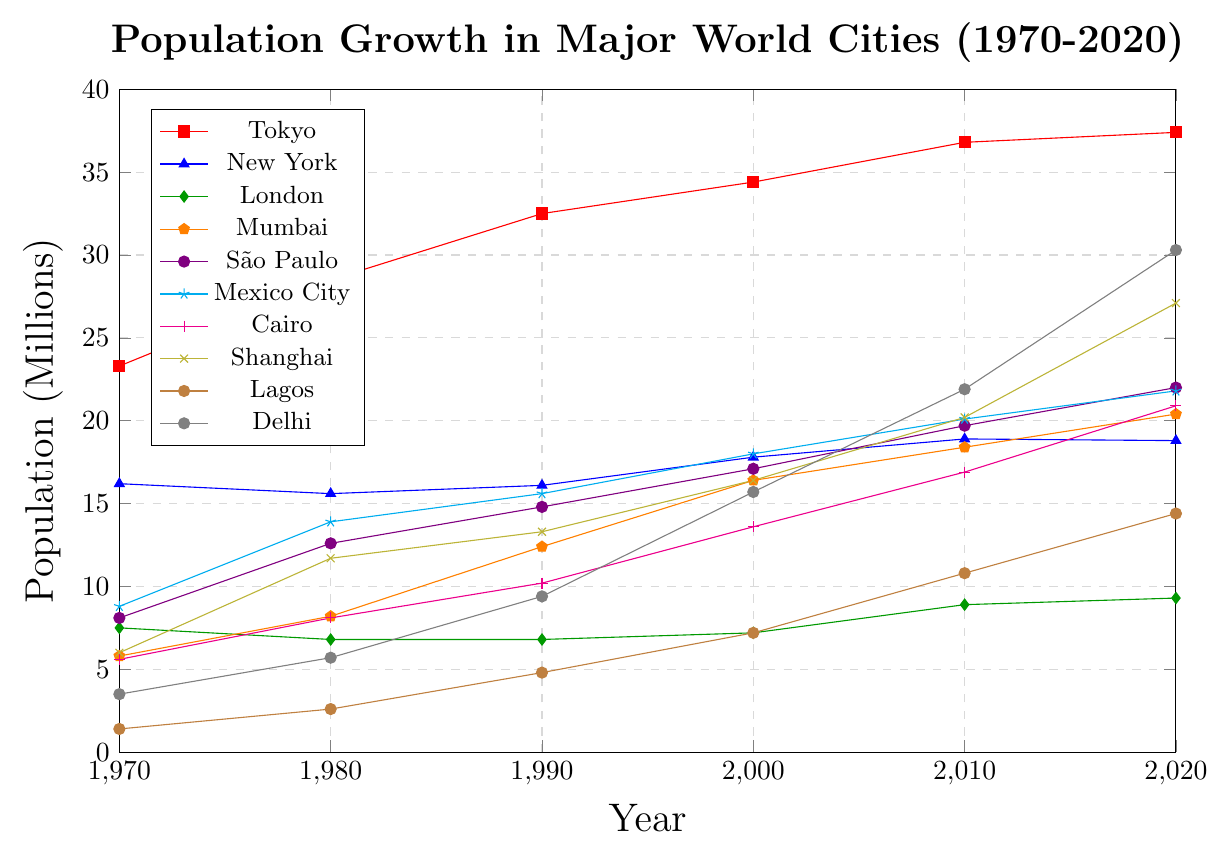Which city had the highest population growth between 1970 and 2020? To determine the highest population growth, subtract the 1970 population from the 2020 population for each city. Tokyo: 37.4 - 23.3 = 14.1, New York: 18.8 - 16.2 = 2.6, London: 9.3 - 7.5 = 1.8, Mumbai: 20.4 - 5.8 = 14.6, São Paulo: 22.0 - 8.1 = 13.9, Mexico City: 21.8 - 8.8 = 13.0, Cairo: 20.9 - 5.6 = 15.3, Shanghai: 27.1 - 6.0 = 21.1, Lagos: 14.4 - 1.4 = 13.0, Delhi: 30.3 - 3.5 = 26.8. The highest is Delhi with 26.8 million.
Answer: Delhi Which city had a population decline between 1970 and 1980? Look at the population values from 1970 and 1980 for each city to see if there was a decline. Tokyo: 23.3 to 28.5, New York: 16.2 to 15.6, London: 7.5 to 6.8, Mumbai: 5.8 to 8.2, São Paulo: 8.1 to 12.6, Mexico City: 8.8 to 13.9, Cairo: 5.6 to 8.1, Shanghai: 6.0 to 11.7, Lagos: 1.4 to 2.6, Delhi: 3.5 to 5.7. Both New York and London experienced declines.
Answer: New York, London Which city saw the fastest growth between 2000 and 2020? Calculate the difference in population between 2000 and 2020 for each city. Tokyo: 37.4 - 34.4 = 3, New York: 18.8 - 17.8 = 1, London: 9.3 - 7.2 = 2.1, Mumbai: 20.4 - 16.4 = 4, São Paulo: 22.0 - 17.1 = 4.9, Mexico City: 21.8 - 18 = 3.8, Cairo: 20.9 - 13.6 = 7.3, Shanghai: 27.1 - 16.4 = 10.7, Lagos: 14.4 - 7.2 = 7.2, Delhi: 30.3 - 15.7 = 14.6. Delhi saw the fastest growth of 14.6 million.
Answer: Delhi Is there any city whose population surpassed 30 million by 2020? Check the population figures for 2020 to see if any city has a population of over 30 million. Delhi: 30.3, Tokyo: 37.4. These cities both meet the criteria.
Answer: Delhi, Tokyo By how much did the population of Lagos increase from 1990 to 2020? Subtract the population of Lagos in 1990 from its population in 2020. Lagos: 14.4 - 4.8 = 9.6 million.
Answer: 9.6 million How many cities had a population of more than 20 million by 2020? Count the number of cities with a population greater than 20 million in the year 2020. Delhi: 30.3, Tokyo: 37.4, Mumbai: 20.4, São Paulo: 22.0, Mexico City: 21.8, Cairo: 20.9, Shanghai: 27.1. There are 7 cities.
Answer: 7 Which city had the smallest population in 1970, and what was the population? Locate the city with the smallest population in the year 1970. Lagos: 1.4 million.
Answer: Lagos, 1.4 million What was the average population of New York over the observed years (1970 to 2020)? Sum the populations of New York for all years and divide by the number of years. (16.2 + 15.6 + 16.1 + 17.8 + 18.9 + 18.8) / 6 = 103.4 / 6 = 17.23 million.
Answer: 17.23 million Which city had the highest population in the year 1990? Find the city with the highest population in 1990. Tokyo: 32.5 million.
Answer: Tokyo Compare the population growth of Cairo and Mumbai between 1970 and 2020. Which city experienced greater growth? Calculate the population difference between 1970 and 2020 for both cities and compare. Cairo: 20.9 - 5.6 = 15.3 million, Mumbai: 20.4 - 5.8 = 14.6 million. Cairo experienced greater growth.
Answer: Cairo 